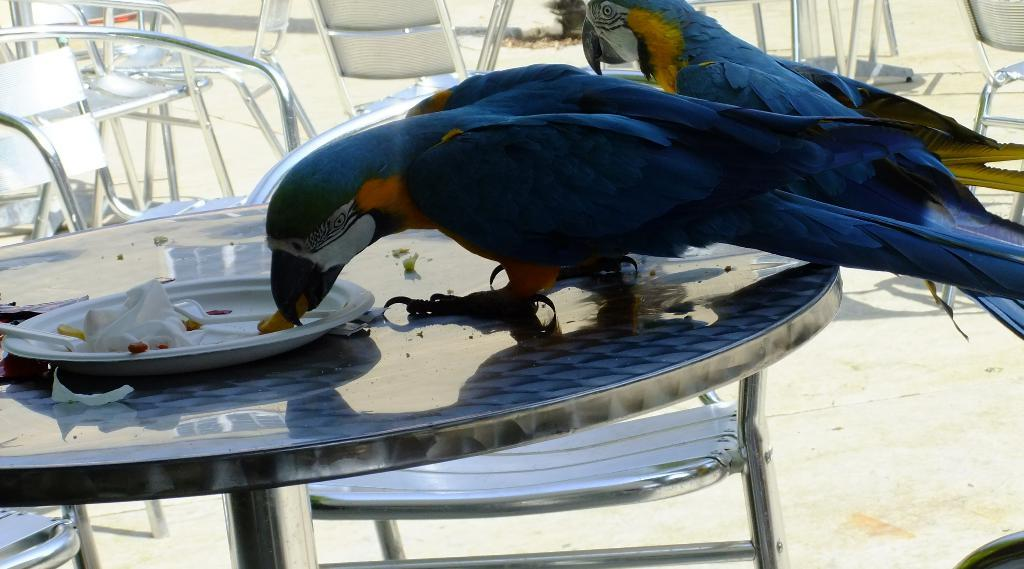Where was the image taken? The image was clicked outside. What animals can be seen in the image? There are two birds in the image. What color are the birds? The birds are blue in color. Where are the birds located in the image? The birds are on a table. What are the birds doing in the image? The birds are eating food. What can be seen to the left of the image? There are many chairs to the left of the image. What is visible at the bottom of the image? There is ground visible at the bottom of the image. What type of quartz can be seen in the image? There is no quartz present in the image. What punishment is being given to the birds in the image? There is no punishment being given to the birds in the image; they are simply eating food. 